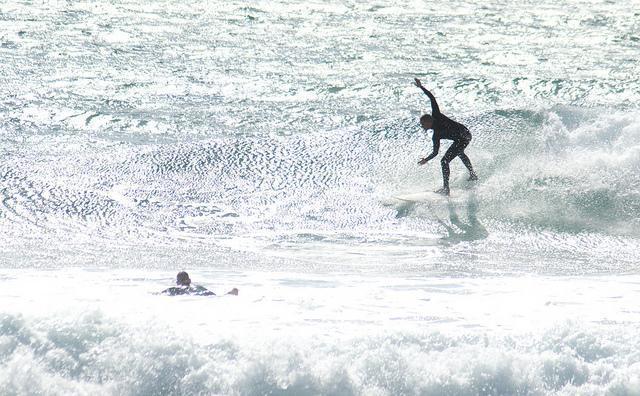How many surfers are in this photo?
Give a very brief answer. 2. How many surfers are there?
Give a very brief answer. 2. 